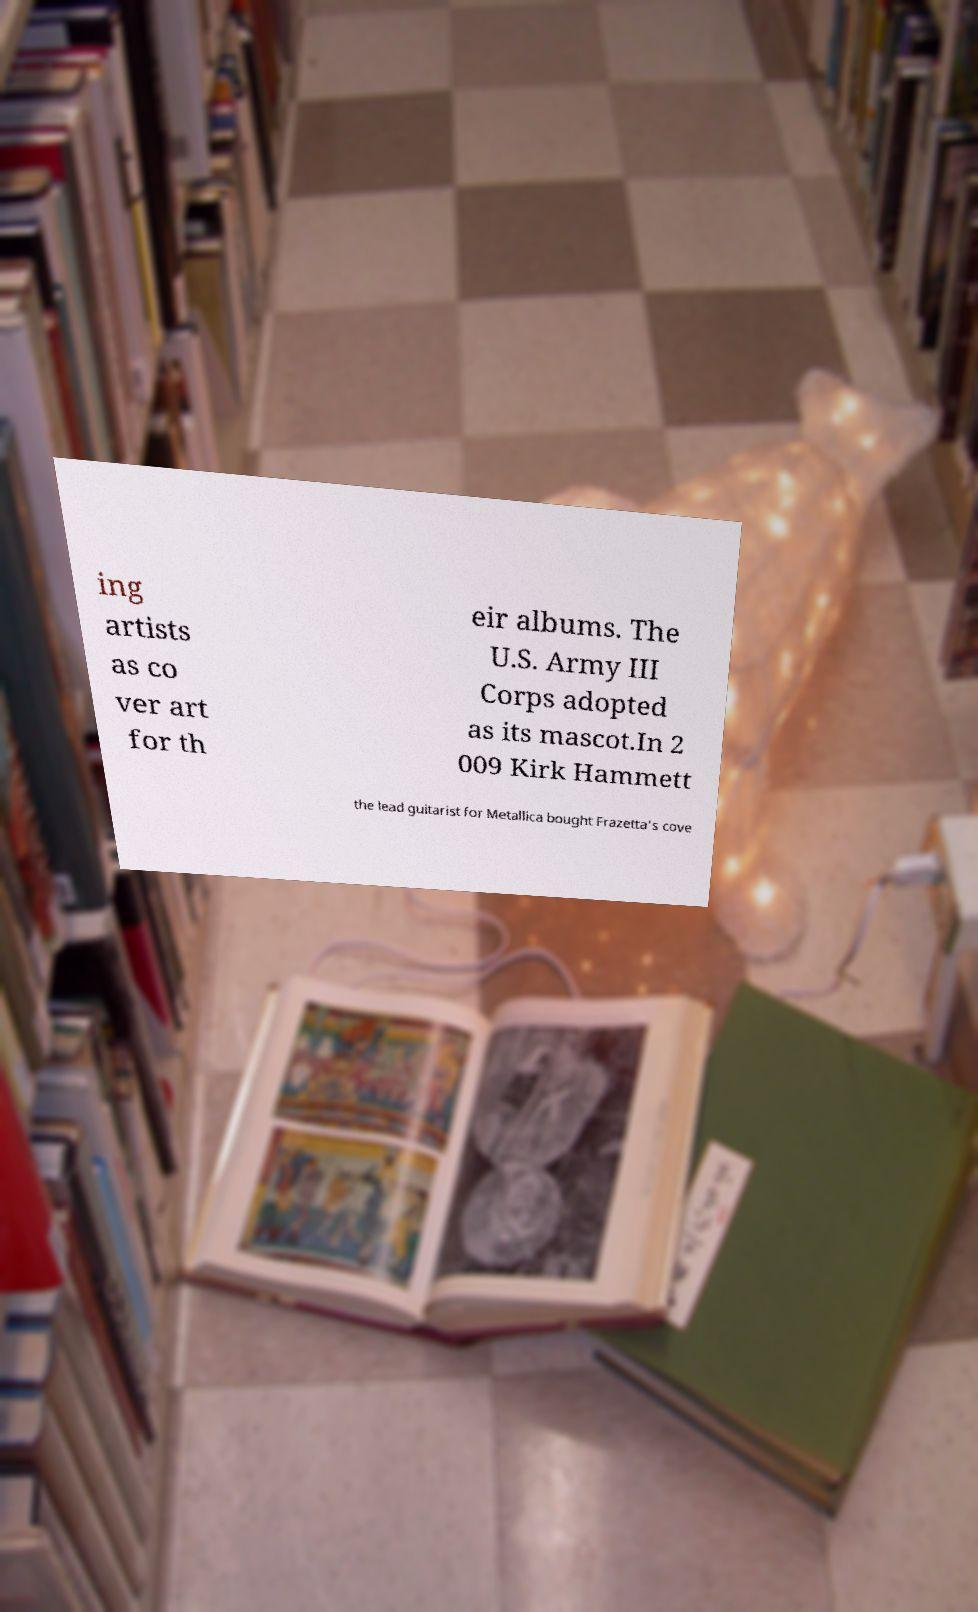There's text embedded in this image that I need extracted. Can you transcribe it verbatim? ing artists as co ver art for th eir albums. The U.S. Army III Corps adopted as its mascot.In 2 009 Kirk Hammett the lead guitarist for Metallica bought Frazetta's cove 